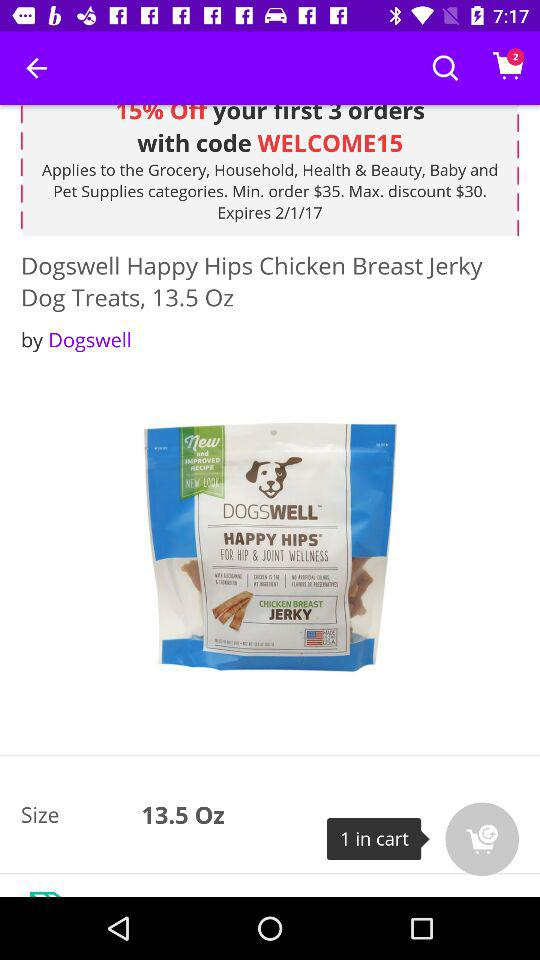How much of a discount is there on the first 3 orders? There is a 15% discount on the first 3 orders. 